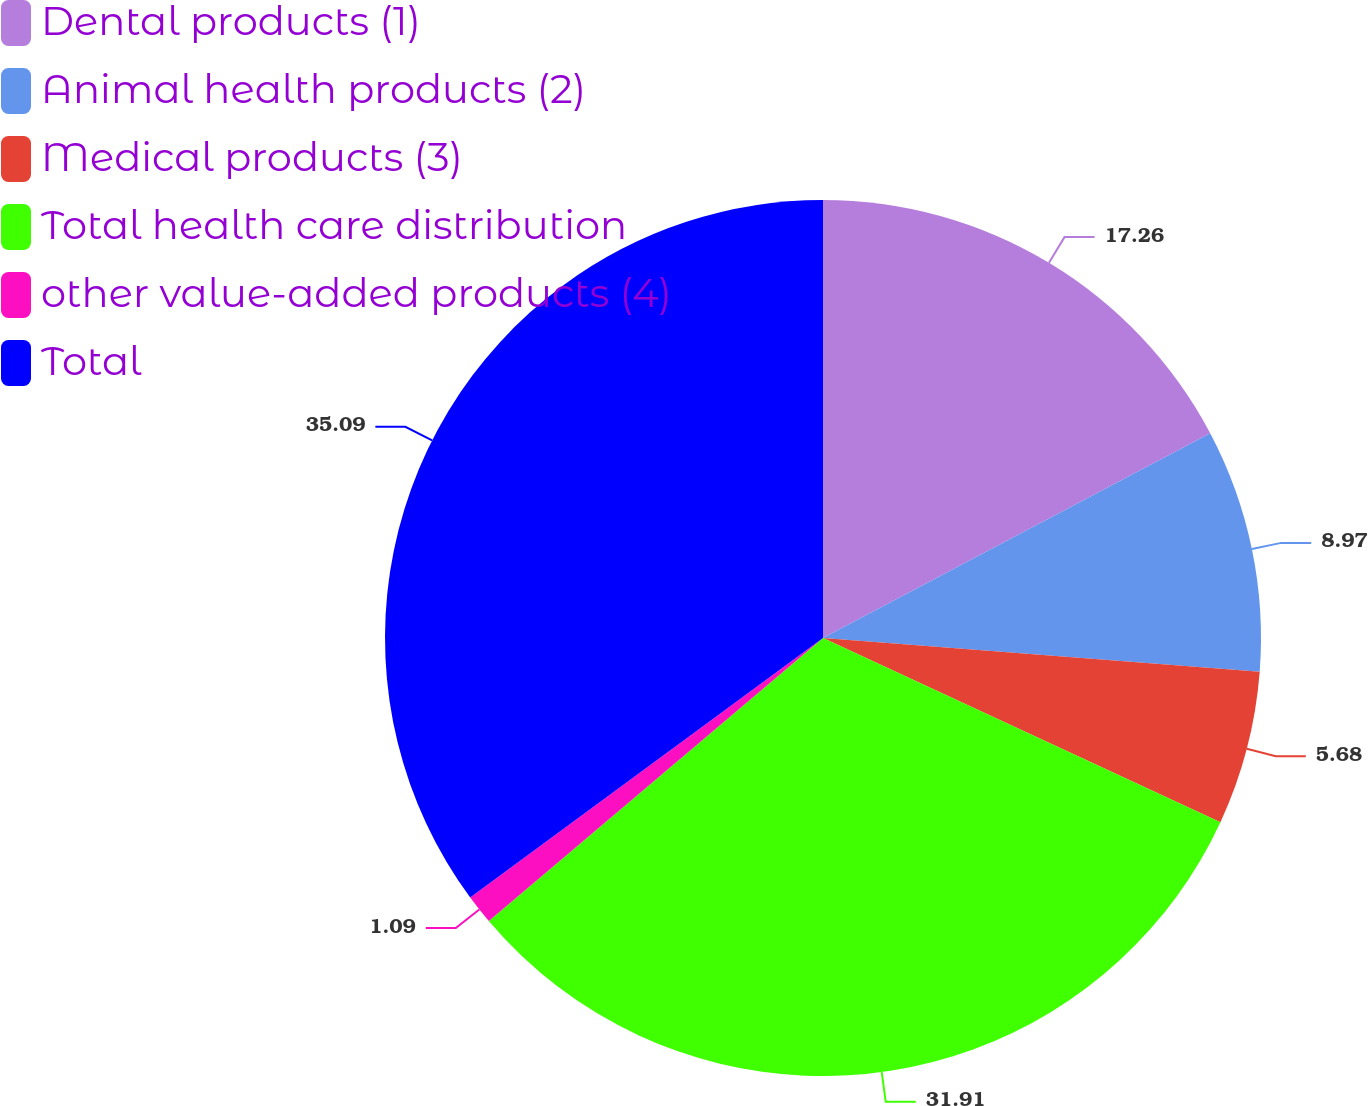Convert chart to OTSL. <chart><loc_0><loc_0><loc_500><loc_500><pie_chart><fcel>Dental products (1)<fcel>Animal health products (2)<fcel>Medical products (3)<fcel>Total health care distribution<fcel>other value-added products (4)<fcel>Total<nl><fcel>17.26%<fcel>8.97%<fcel>5.68%<fcel>31.91%<fcel>1.09%<fcel>35.1%<nl></chart> 